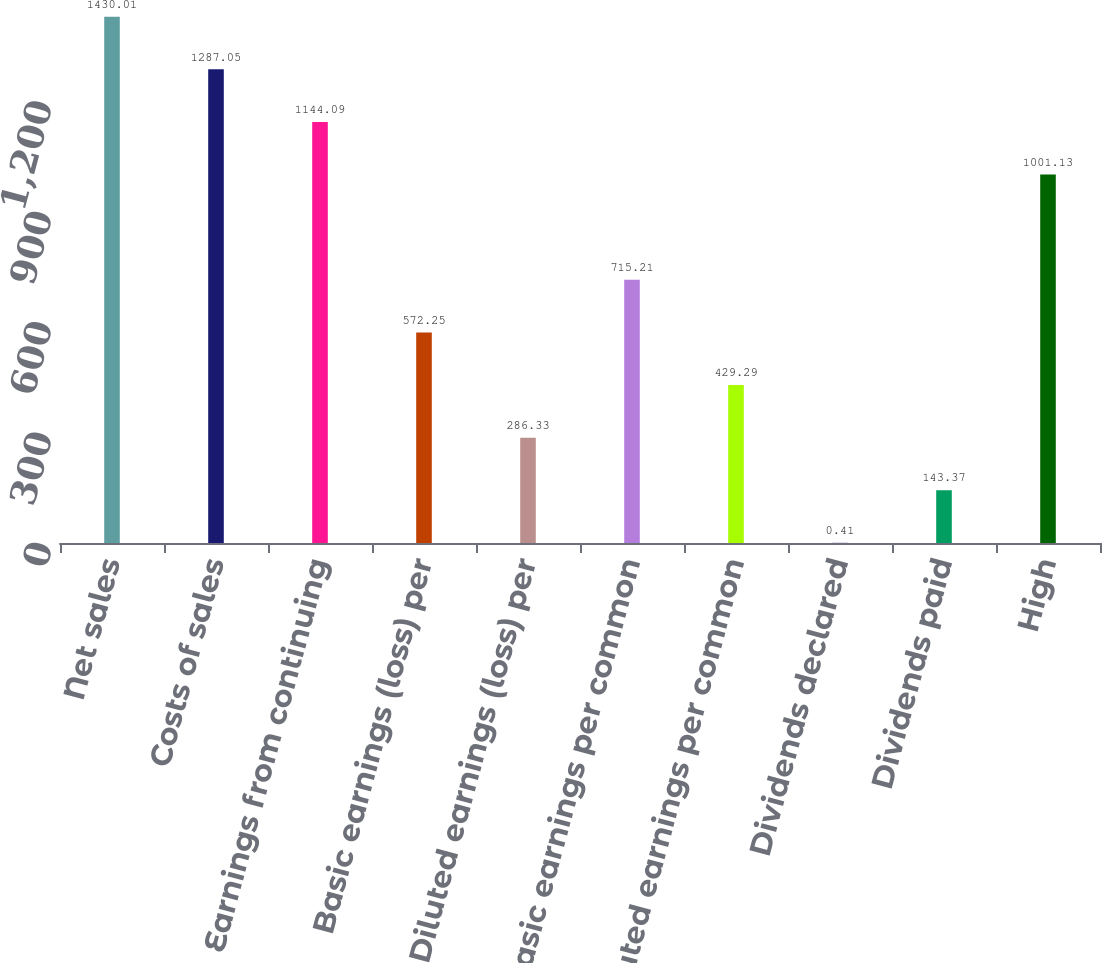Convert chart. <chart><loc_0><loc_0><loc_500><loc_500><bar_chart><fcel>Net sales<fcel>Costs of sales<fcel>Earnings from continuing<fcel>Basic earnings (loss) per<fcel>Diluted earnings (loss) per<fcel>Basic earnings per common<fcel>Diluted earnings per common<fcel>Dividends declared<fcel>Dividends paid<fcel>High<nl><fcel>1430.01<fcel>1287.05<fcel>1144.09<fcel>572.25<fcel>286.33<fcel>715.21<fcel>429.29<fcel>0.41<fcel>143.37<fcel>1001.13<nl></chart> 